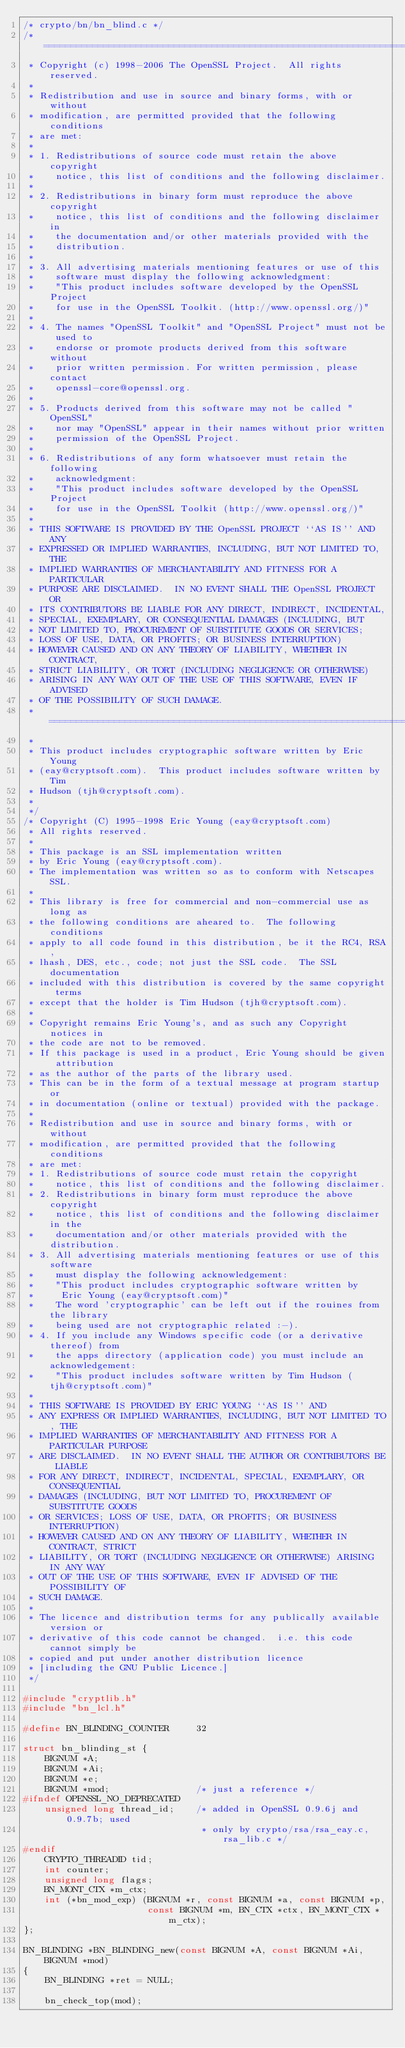<code> <loc_0><loc_0><loc_500><loc_500><_C_>/* crypto/bn/bn_blind.c */
/* ====================================================================
 * Copyright (c) 1998-2006 The OpenSSL Project.  All rights reserved.
 *
 * Redistribution and use in source and binary forms, with or without
 * modification, are permitted provided that the following conditions
 * are met:
 *
 * 1. Redistributions of source code must retain the above copyright
 *    notice, this list of conditions and the following disclaimer.
 *
 * 2. Redistributions in binary form must reproduce the above copyright
 *    notice, this list of conditions and the following disclaimer in
 *    the documentation and/or other materials provided with the
 *    distribution.
 *
 * 3. All advertising materials mentioning features or use of this
 *    software must display the following acknowledgment:
 *    "This product includes software developed by the OpenSSL Project
 *    for use in the OpenSSL Toolkit. (http://www.openssl.org/)"
 *
 * 4. The names "OpenSSL Toolkit" and "OpenSSL Project" must not be used to
 *    endorse or promote products derived from this software without
 *    prior written permission. For written permission, please contact
 *    openssl-core@openssl.org.
 *
 * 5. Products derived from this software may not be called "OpenSSL"
 *    nor may "OpenSSL" appear in their names without prior written
 *    permission of the OpenSSL Project.
 *
 * 6. Redistributions of any form whatsoever must retain the following
 *    acknowledgment:
 *    "This product includes software developed by the OpenSSL Project
 *    for use in the OpenSSL Toolkit (http://www.openssl.org/)"
 *
 * THIS SOFTWARE IS PROVIDED BY THE OpenSSL PROJECT ``AS IS'' AND ANY
 * EXPRESSED OR IMPLIED WARRANTIES, INCLUDING, BUT NOT LIMITED TO, THE
 * IMPLIED WARRANTIES OF MERCHANTABILITY AND FITNESS FOR A PARTICULAR
 * PURPOSE ARE DISCLAIMED.  IN NO EVENT SHALL THE OpenSSL PROJECT OR
 * ITS CONTRIBUTORS BE LIABLE FOR ANY DIRECT, INDIRECT, INCIDENTAL,
 * SPECIAL, EXEMPLARY, OR CONSEQUENTIAL DAMAGES (INCLUDING, BUT
 * NOT LIMITED TO, PROCUREMENT OF SUBSTITUTE GOODS OR SERVICES;
 * LOSS OF USE, DATA, OR PROFITS; OR BUSINESS INTERRUPTION)
 * HOWEVER CAUSED AND ON ANY THEORY OF LIABILITY, WHETHER IN CONTRACT,
 * STRICT LIABILITY, OR TORT (INCLUDING NEGLIGENCE OR OTHERWISE)
 * ARISING IN ANY WAY OUT OF THE USE OF THIS SOFTWARE, EVEN IF ADVISED
 * OF THE POSSIBILITY OF SUCH DAMAGE.
 * ====================================================================
 *
 * This product includes cryptographic software written by Eric Young
 * (eay@cryptsoft.com).  This product includes software written by Tim
 * Hudson (tjh@cryptsoft.com).
 *
 */
/* Copyright (C) 1995-1998 Eric Young (eay@cryptsoft.com)
 * All rights reserved.
 *
 * This package is an SSL implementation written
 * by Eric Young (eay@cryptsoft.com).
 * The implementation was written so as to conform with Netscapes SSL.
 *
 * This library is free for commercial and non-commercial use as long as
 * the following conditions are aheared to.  The following conditions
 * apply to all code found in this distribution, be it the RC4, RSA,
 * lhash, DES, etc., code; not just the SSL code.  The SSL documentation
 * included with this distribution is covered by the same copyright terms
 * except that the holder is Tim Hudson (tjh@cryptsoft.com).
 *
 * Copyright remains Eric Young's, and as such any Copyright notices in
 * the code are not to be removed.
 * If this package is used in a product, Eric Young should be given attribution
 * as the author of the parts of the library used.
 * This can be in the form of a textual message at program startup or
 * in documentation (online or textual) provided with the package.
 *
 * Redistribution and use in source and binary forms, with or without
 * modification, are permitted provided that the following conditions
 * are met:
 * 1. Redistributions of source code must retain the copyright
 *    notice, this list of conditions and the following disclaimer.
 * 2. Redistributions in binary form must reproduce the above copyright
 *    notice, this list of conditions and the following disclaimer in the
 *    documentation and/or other materials provided with the distribution.
 * 3. All advertising materials mentioning features or use of this software
 *    must display the following acknowledgement:
 *    "This product includes cryptographic software written by
 *     Eric Young (eay@cryptsoft.com)"
 *    The word 'cryptographic' can be left out if the rouines from the library
 *    being used are not cryptographic related :-).
 * 4. If you include any Windows specific code (or a derivative thereof) from
 *    the apps directory (application code) you must include an acknowledgement:
 *    "This product includes software written by Tim Hudson (tjh@cryptsoft.com)"
 *
 * THIS SOFTWARE IS PROVIDED BY ERIC YOUNG ``AS IS'' AND
 * ANY EXPRESS OR IMPLIED WARRANTIES, INCLUDING, BUT NOT LIMITED TO, THE
 * IMPLIED WARRANTIES OF MERCHANTABILITY AND FITNESS FOR A PARTICULAR PURPOSE
 * ARE DISCLAIMED.  IN NO EVENT SHALL THE AUTHOR OR CONTRIBUTORS BE LIABLE
 * FOR ANY DIRECT, INDIRECT, INCIDENTAL, SPECIAL, EXEMPLARY, OR CONSEQUENTIAL
 * DAMAGES (INCLUDING, BUT NOT LIMITED TO, PROCUREMENT OF SUBSTITUTE GOODS
 * OR SERVICES; LOSS OF USE, DATA, OR PROFITS; OR BUSINESS INTERRUPTION)
 * HOWEVER CAUSED AND ON ANY THEORY OF LIABILITY, WHETHER IN CONTRACT, STRICT
 * LIABILITY, OR TORT (INCLUDING NEGLIGENCE OR OTHERWISE) ARISING IN ANY WAY
 * OUT OF THE USE OF THIS SOFTWARE, EVEN IF ADVISED OF THE POSSIBILITY OF
 * SUCH DAMAGE.
 *
 * The licence and distribution terms for any publically available version or
 * derivative of this code cannot be changed.  i.e. this code cannot simply be
 * copied and put under another distribution licence
 * [including the GNU Public Licence.]
 */

#include "cryptlib.h"
#include "bn_lcl.h"

#define BN_BLINDING_COUNTER     32

struct bn_blinding_st {
    BIGNUM *A;
    BIGNUM *Ai;
    BIGNUM *e;
    BIGNUM *mod;                /* just a reference */
#ifndef OPENSSL_NO_DEPRECATED
    unsigned long thread_id;    /* added in OpenSSL 0.9.6j and 0.9.7b; used
                                 * only by crypto/rsa/rsa_eay.c, rsa_lib.c */
#endif
    CRYPTO_THREADID tid;
    int counter;
    unsigned long flags;
    BN_MONT_CTX *m_ctx;
    int (*bn_mod_exp) (BIGNUM *r, const BIGNUM *a, const BIGNUM *p,
                       const BIGNUM *m, BN_CTX *ctx, BN_MONT_CTX *m_ctx);
};

BN_BLINDING *BN_BLINDING_new(const BIGNUM *A, const BIGNUM *Ai, BIGNUM *mod)
{
    BN_BLINDING *ret = NULL;

    bn_check_top(mod);
</code> 